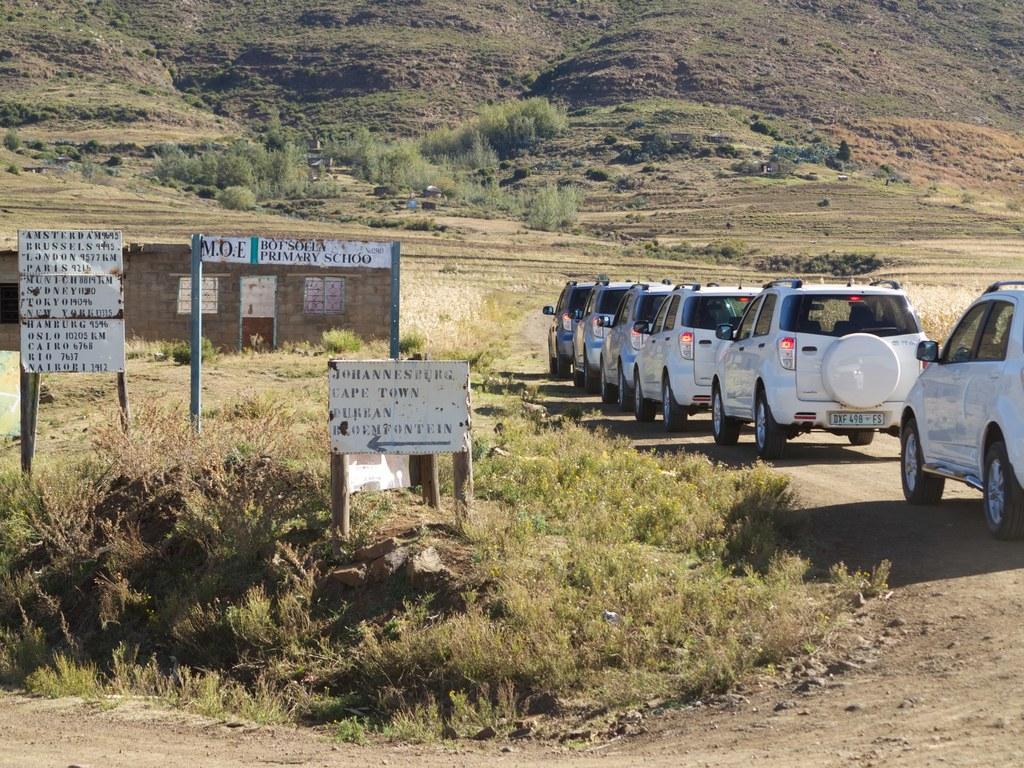How would you summarize this image in a sentence or two? In this image, there are a few vehicles. We can see the ground. We can also see some grass, plants and poles. We can see some boards with text. We can also see a house. 